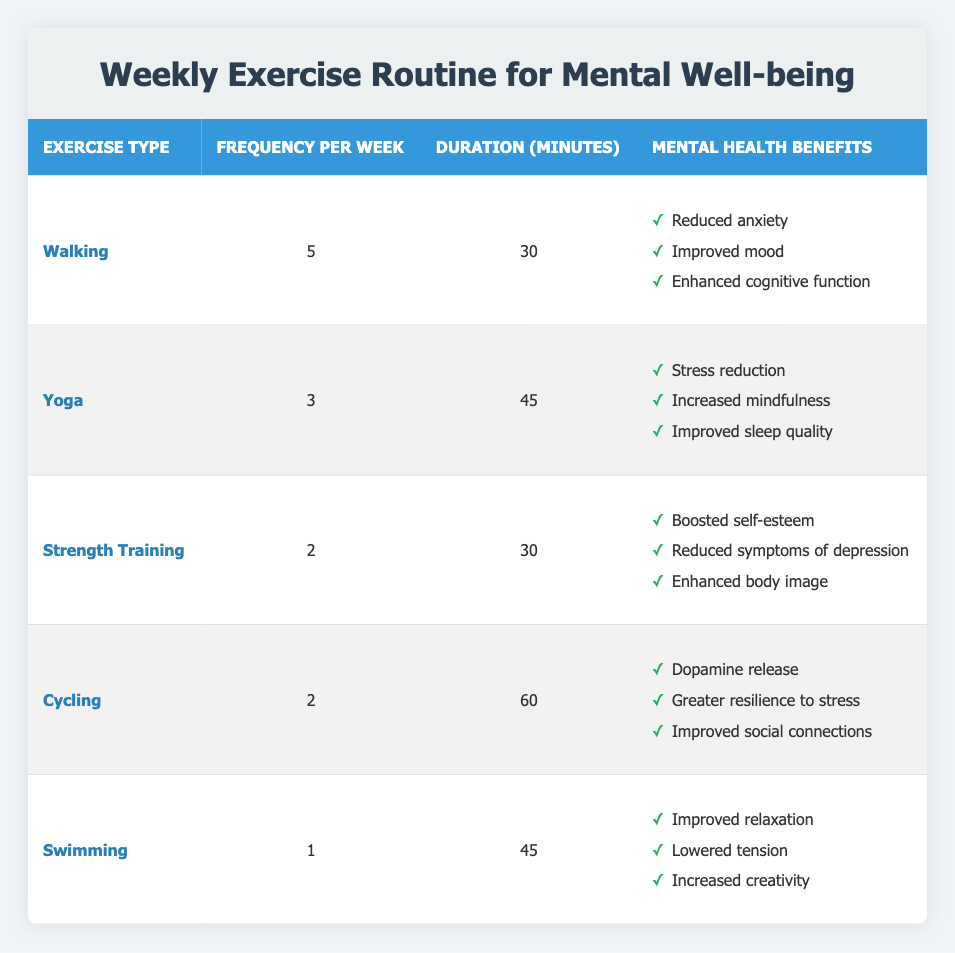What is the frequency per week for yoga? The table lists yoga with a frequency of 3 times per week. This information is directly found under the "Frequency per Week" column for the "Yoga" exercise type.
Answer: 3 How many minutes do you need to spend on strength training in a week? Strength training is listed with a duration of 30 minutes per session and it occurs 2 times per week. Therefore, the total time spent per week on strength training is 30 minutes x 2 = 60 minutes.
Answer: 60 minutes Which exercise has the benefit of improved sleep quality? The benefit of improved sleep quality is specifically listed under the yoga exercise type. You can find this under the "Mental Health Benefits" section corresponding to yoga.
Answer: Yoga Is walking the most frequent exercise listed? Yes, walking has the highest frequency at 5 times per week compared to other exercises listed in the table.
Answer: Yes What are the total mental health benefits associated with cycling? Cycling provides 3 specific benefits: dopamine release, greater resilience to stress, and improved social connections. These are listed under the "Mental Health Benefits" section for cycling. Count these benefits to confirm that there are indeed three.
Answer: 3 What is the average duration of all exercises per session? To find the average duration, add the duration of each exercise (30 + 45 + 30 + 60 + 45 = 210 minutes) and divide by the number of exercises (5). The calculation gives 210/5 = 42 minutes as the average duration.
Answer: 42 minutes Is swimming done more frequently than strength training? No, swimming occurs only once a week, while strength training occurs twice a week. Comparing these frequencies shows that strength training is more frequent.
Answer: No Which exercise has the least frequency per week? The exercise with the least frequency per week is swimming, which is done just 1 time per week, according to the "Frequency per Week" column.
Answer: Swimming 